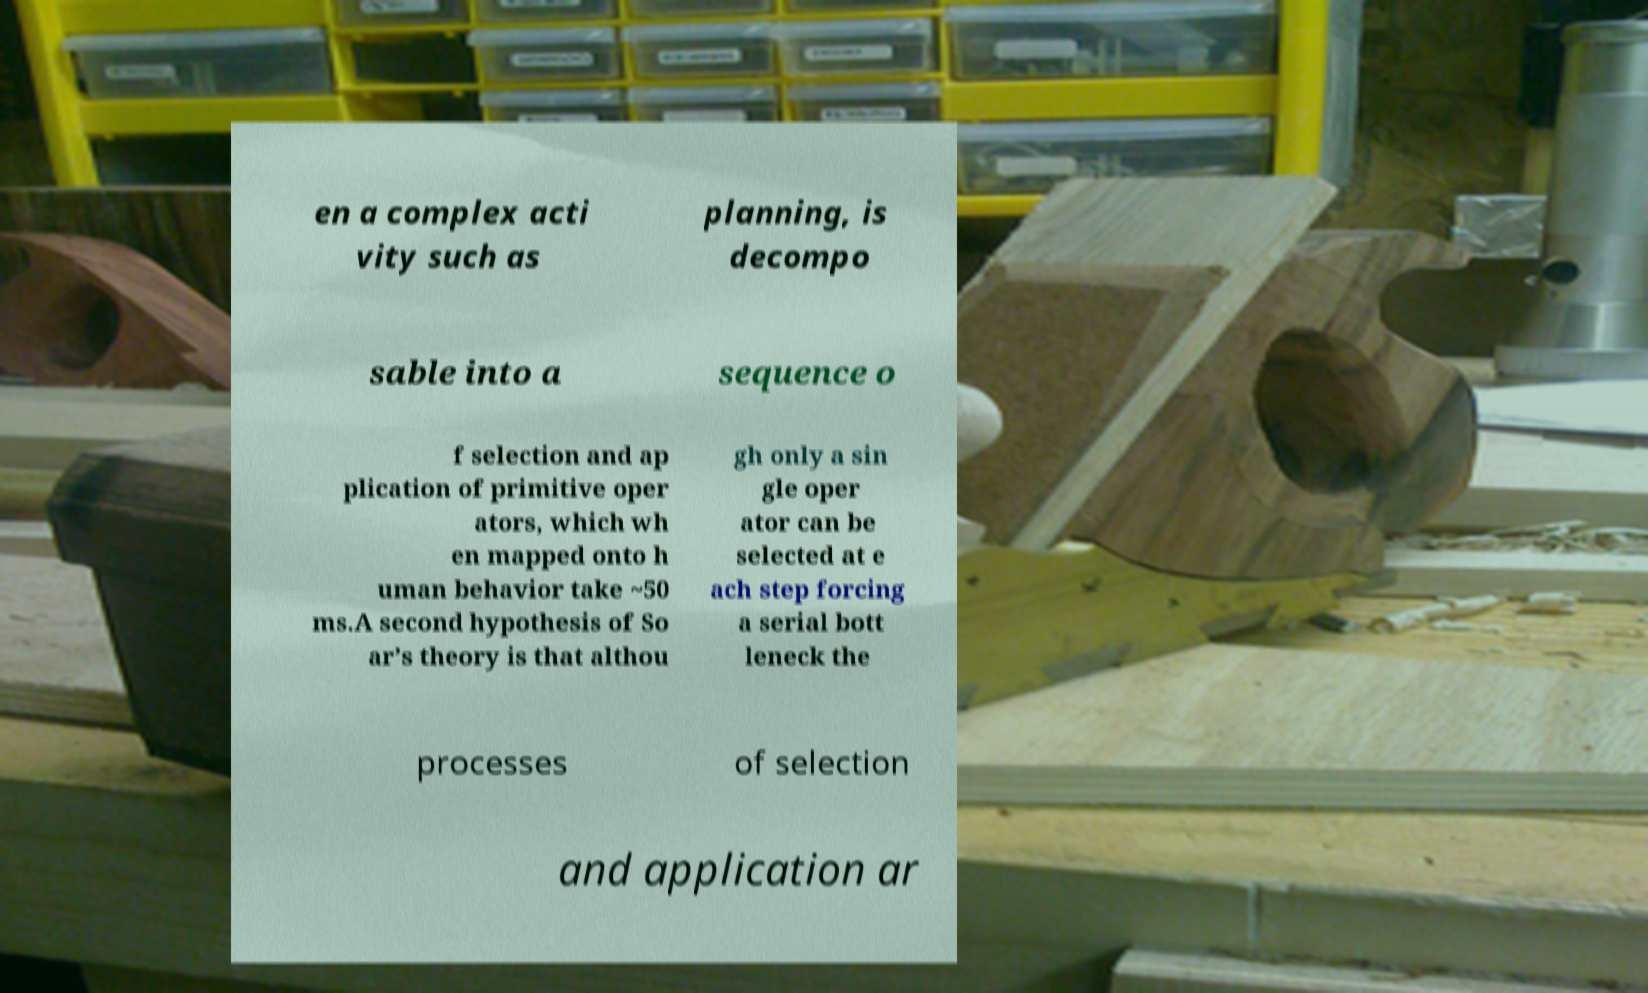For documentation purposes, I need the text within this image transcribed. Could you provide that? en a complex acti vity such as planning, is decompo sable into a sequence o f selection and ap plication of primitive oper ators, which wh en mapped onto h uman behavior take ~50 ms.A second hypothesis of So ar’s theory is that althou gh only a sin gle oper ator can be selected at e ach step forcing a serial bott leneck the processes of selection and application ar 